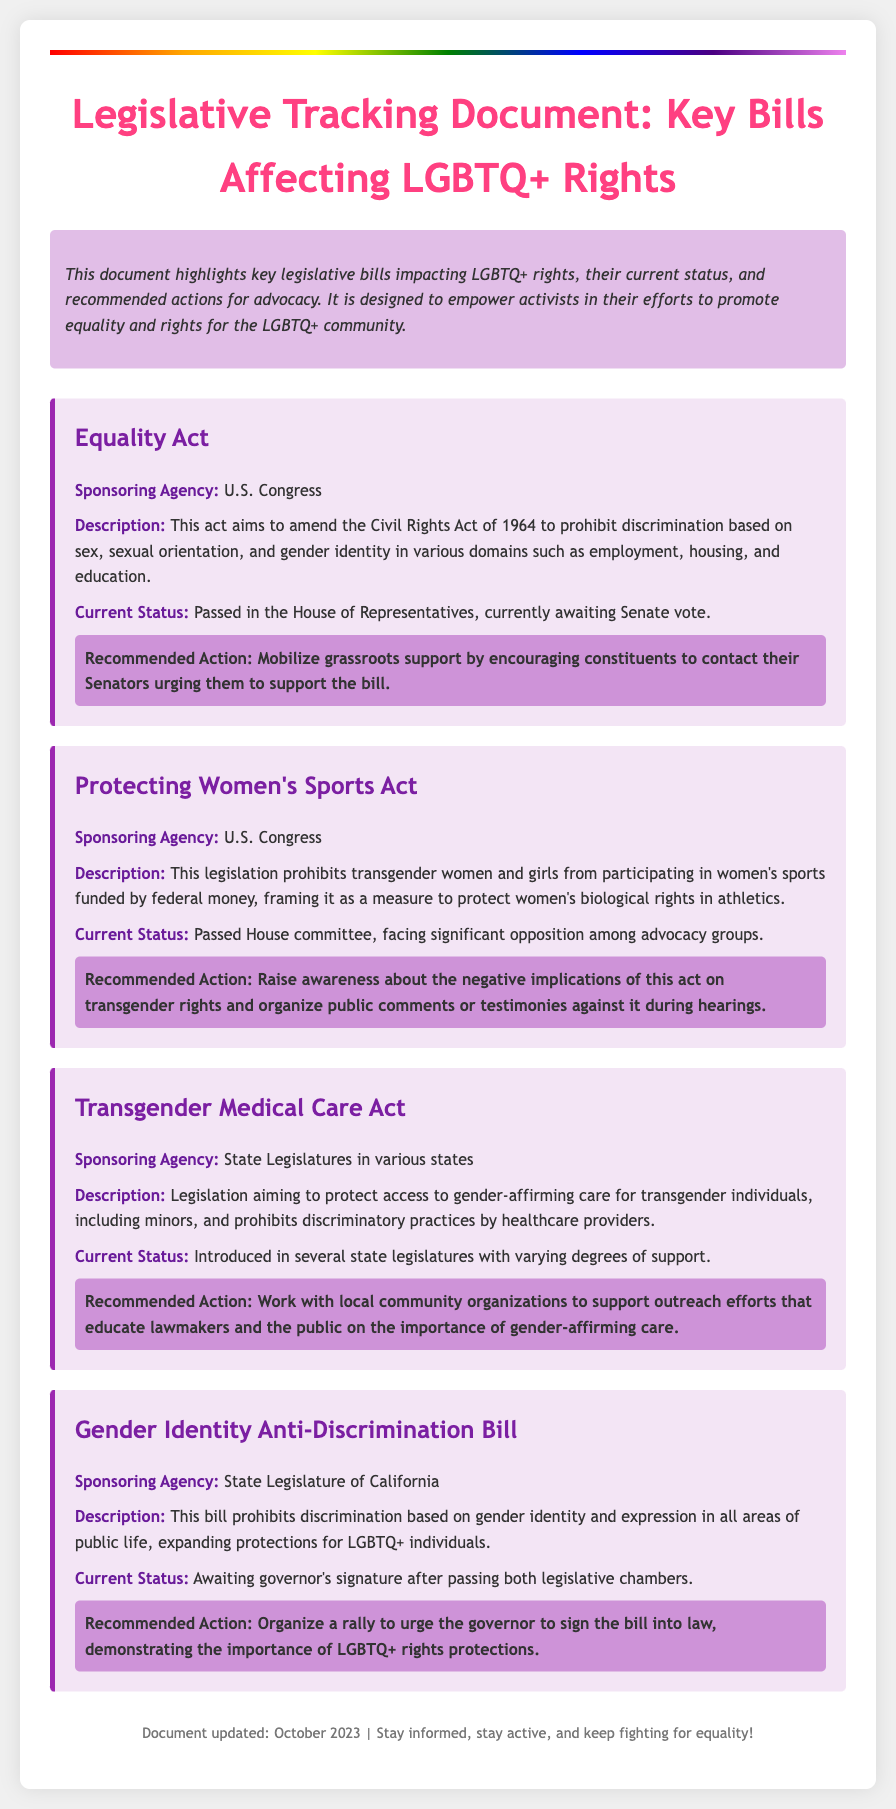What is the title of the document? The title of the document is indicated prominently at the top of the rendered document, outlining its purpose related to LGBTQ+ rights.
Answer: Legislative Tracking Document: Key Bills Affecting LGBTQ+ Rights Who sponsors the Equality Act? The sponsoring agency for the Equality Act is mentioned in the bill section, providing the organizational context.
Answer: U.S. Congress What is the current status of the Gender Identity Anti-Discrimination Bill? The current status is detailed in the document, indicating the legislative progress for the bill.
Answer: Awaiting governor's signature after passing both legislative chambers What action is recommended for the Protecting Women's Sports Act? The recommended actions are provided for each bill, summarizing the suggested advocacy efforts.
Answer: Raise awareness about the negative implications of this act on transgender rights and organize public comments or testimonies against it during hearings What does the Transgender Medical Care Act aim to protect? The document describes the purpose of the Transgender Medical Care Act, specifying its focus on healthcare access.
Answer: Access to gender-affirming care for transgender individuals How many bills are highlighted in this document? The number of bills can be counted from the individual bill sections presented in the document.
Answer: Four bills What color is the rainbow bar at the top of the document? The visual element at the top serves as a symbol, with its colors indicating diversity and inclusion.
Answer: Rainbow What is the main objective of the document? The objective of the document is stated in the summary, encapsulating its focus on advocacy and awareness.
Answer: To empower activists in their efforts to promote equality and rights for the LGBTQ+ community 